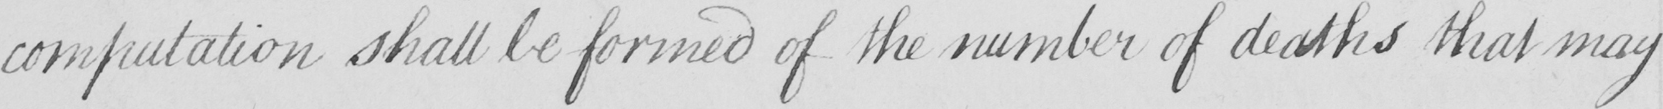Transcribe the text shown in this historical manuscript line. computation shall be formed of the number of deaths that may 